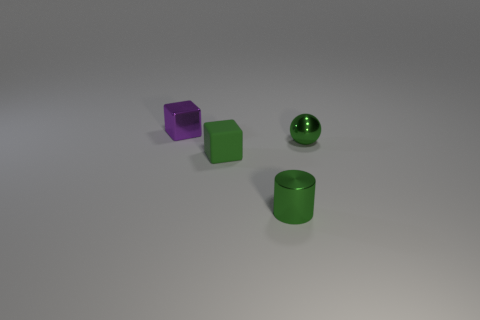Add 2 shiny cylinders. How many objects exist? 6 Subtract all red blocks. Subtract all green cylinders. How many blocks are left? 2 Subtract all large red matte things. Subtract all green metallic cylinders. How many objects are left? 3 Add 2 green spheres. How many green spheres are left? 3 Add 2 blue rubber objects. How many blue rubber objects exist? 2 Subtract 0 yellow cylinders. How many objects are left? 4 Subtract all cylinders. How many objects are left? 3 